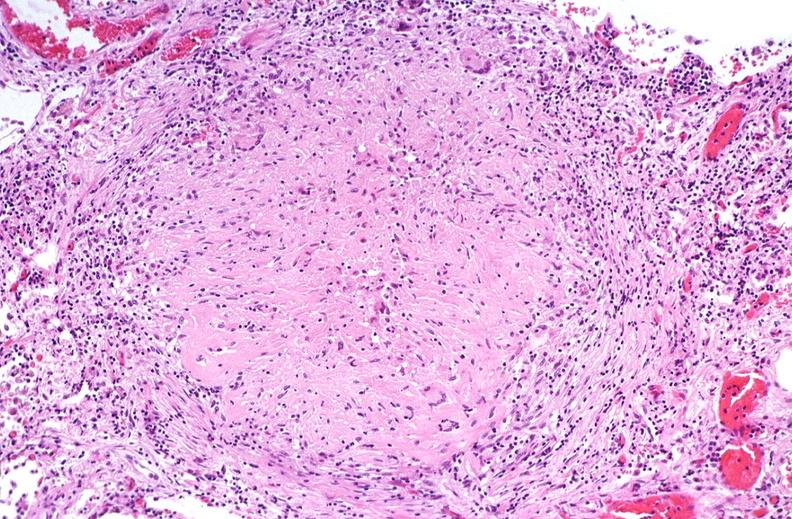does this image show lung, mycobacterium tuberculosis, granulomas and giant cells?
Answer the question using a single word or phrase. Yes 